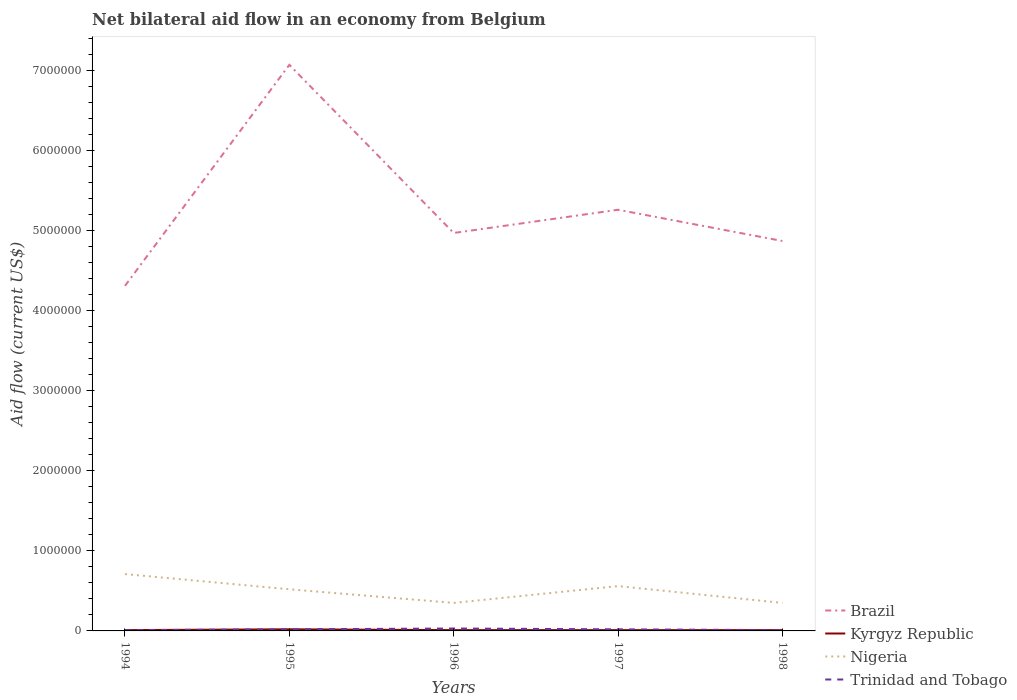How many different coloured lines are there?
Offer a terse response. 4. What is the total net bilateral aid flow in Kyrgyz Republic in the graph?
Provide a short and direct response. 10000. What is the difference between the highest and the lowest net bilateral aid flow in Kyrgyz Republic?
Your answer should be very brief. 1. What is the difference between two consecutive major ticks on the Y-axis?
Provide a short and direct response. 1.00e+06. Are the values on the major ticks of Y-axis written in scientific E-notation?
Your answer should be compact. No. Does the graph contain any zero values?
Your answer should be very brief. No. Does the graph contain grids?
Ensure brevity in your answer.  No. Where does the legend appear in the graph?
Provide a succinct answer. Bottom right. How are the legend labels stacked?
Give a very brief answer. Vertical. What is the title of the graph?
Offer a terse response. Net bilateral aid flow in an economy from Belgium. What is the Aid flow (current US$) of Brazil in 1994?
Your response must be concise. 4.31e+06. What is the Aid flow (current US$) in Nigeria in 1994?
Your answer should be very brief. 7.10e+05. What is the Aid flow (current US$) in Trinidad and Tobago in 1994?
Provide a short and direct response. 10000. What is the Aid flow (current US$) in Brazil in 1995?
Provide a succinct answer. 7.07e+06. What is the Aid flow (current US$) of Nigeria in 1995?
Provide a succinct answer. 5.20e+05. What is the Aid flow (current US$) of Brazil in 1996?
Keep it short and to the point. 4.97e+06. What is the Aid flow (current US$) of Kyrgyz Republic in 1996?
Keep it short and to the point. 10000. What is the Aid flow (current US$) in Nigeria in 1996?
Offer a terse response. 3.50e+05. What is the Aid flow (current US$) in Brazil in 1997?
Your response must be concise. 5.26e+06. What is the Aid flow (current US$) of Nigeria in 1997?
Give a very brief answer. 5.60e+05. What is the Aid flow (current US$) in Trinidad and Tobago in 1997?
Give a very brief answer. 2.00e+04. What is the Aid flow (current US$) in Brazil in 1998?
Offer a terse response. 4.87e+06. What is the Aid flow (current US$) in Kyrgyz Republic in 1998?
Your answer should be compact. 10000. Across all years, what is the maximum Aid flow (current US$) in Brazil?
Offer a very short reply. 7.07e+06. Across all years, what is the maximum Aid flow (current US$) in Kyrgyz Republic?
Provide a succinct answer. 2.00e+04. Across all years, what is the maximum Aid flow (current US$) in Nigeria?
Your answer should be very brief. 7.10e+05. Across all years, what is the minimum Aid flow (current US$) in Brazil?
Offer a terse response. 4.31e+06. Across all years, what is the minimum Aid flow (current US$) of Kyrgyz Republic?
Your response must be concise. 10000. Across all years, what is the minimum Aid flow (current US$) of Nigeria?
Your answer should be very brief. 3.50e+05. Across all years, what is the minimum Aid flow (current US$) in Trinidad and Tobago?
Your answer should be very brief. 10000. What is the total Aid flow (current US$) in Brazil in the graph?
Provide a short and direct response. 2.65e+07. What is the total Aid flow (current US$) in Nigeria in the graph?
Keep it short and to the point. 2.49e+06. What is the difference between the Aid flow (current US$) of Brazil in 1994 and that in 1995?
Your answer should be compact. -2.76e+06. What is the difference between the Aid flow (current US$) of Trinidad and Tobago in 1994 and that in 1995?
Provide a succinct answer. -10000. What is the difference between the Aid flow (current US$) in Brazil in 1994 and that in 1996?
Provide a succinct answer. -6.60e+05. What is the difference between the Aid flow (current US$) in Kyrgyz Republic in 1994 and that in 1996?
Provide a succinct answer. 0. What is the difference between the Aid flow (current US$) of Nigeria in 1994 and that in 1996?
Your answer should be compact. 3.60e+05. What is the difference between the Aid flow (current US$) in Brazil in 1994 and that in 1997?
Provide a succinct answer. -9.50e+05. What is the difference between the Aid flow (current US$) of Trinidad and Tobago in 1994 and that in 1997?
Ensure brevity in your answer.  -10000. What is the difference between the Aid flow (current US$) in Brazil in 1994 and that in 1998?
Your answer should be very brief. -5.60e+05. What is the difference between the Aid flow (current US$) in Trinidad and Tobago in 1994 and that in 1998?
Your answer should be very brief. 0. What is the difference between the Aid flow (current US$) of Brazil in 1995 and that in 1996?
Provide a short and direct response. 2.10e+06. What is the difference between the Aid flow (current US$) of Kyrgyz Republic in 1995 and that in 1996?
Offer a very short reply. 10000. What is the difference between the Aid flow (current US$) in Nigeria in 1995 and that in 1996?
Ensure brevity in your answer.  1.70e+05. What is the difference between the Aid flow (current US$) in Brazil in 1995 and that in 1997?
Keep it short and to the point. 1.81e+06. What is the difference between the Aid flow (current US$) of Kyrgyz Republic in 1995 and that in 1997?
Make the answer very short. 10000. What is the difference between the Aid flow (current US$) of Brazil in 1995 and that in 1998?
Offer a very short reply. 2.20e+06. What is the difference between the Aid flow (current US$) of Kyrgyz Republic in 1995 and that in 1998?
Provide a succinct answer. 10000. What is the difference between the Aid flow (current US$) in Nigeria in 1995 and that in 1998?
Provide a short and direct response. 1.70e+05. What is the difference between the Aid flow (current US$) in Brazil in 1996 and that in 1997?
Your answer should be compact. -2.90e+05. What is the difference between the Aid flow (current US$) in Kyrgyz Republic in 1996 and that in 1997?
Ensure brevity in your answer.  0. What is the difference between the Aid flow (current US$) in Brazil in 1996 and that in 1998?
Keep it short and to the point. 1.00e+05. What is the difference between the Aid flow (current US$) of Brazil in 1997 and that in 1998?
Make the answer very short. 3.90e+05. What is the difference between the Aid flow (current US$) in Nigeria in 1997 and that in 1998?
Your response must be concise. 2.10e+05. What is the difference between the Aid flow (current US$) in Brazil in 1994 and the Aid flow (current US$) in Kyrgyz Republic in 1995?
Your answer should be compact. 4.29e+06. What is the difference between the Aid flow (current US$) of Brazil in 1994 and the Aid flow (current US$) of Nigeria in 1995?
Your response must be concise. 3.79e+06. What is the difference between the Aid flow (current US$) in Brazil in 1994 and the Aid flow (current US$) in Trinidad and Tobago in 1995?
Offer a very short reply. 4.29e+06. What is the difference between the Aid flow (current US$) of Kyrgyz Republic in 1994 and the Aid flow (current US$) of Nigeria in 1995?
Offer a very short reply. -5.10e+05. What is the difference between the Aid flow (current US$) of Nigeria in 1994 and the Aid flow (current US$) of Trinidad and Tobago in 1995?
Offer a very short reply. 6.90e+05. What is the difference between the Aid flow (current US$) of Brazil in 1994 and the Aid flow (current US$) of Kyrgyz Republic in 1996?
Your response must be concise. 4.30e+06. What is the difference between the Aid flow (current US$) of Brazil in 1994 and the Aid flow (current US$) of Nigeria in 1996?
Your response must be concise. 3.96e+06. What is the difference between the Aid flow (current US$) in Brazil in 1994 and the Aid flow (current US$) in Trinidad and Tobago in 1996?
Offer a terse response. 4.28e+06. What is the difference between the Aid flow (current US$) in Nigeria in 1994 and the Aid flow (current US$) in Trinidad and Tobago in 1996?
Provide a short and direct response. 6.80e+05. What is the difference between the Aid flow (current US$) of Brazil in 1994 and the Aid flow (current US$) of Kyrgyz Republic in 1997?
Give a very brief answer. 4.30e+06. What is the difference between the Aid flow (current US$) of Brazil in 1994 and the Aid flow (current US$) of Nigeria in 1997?
Ensure brevity in your answer.  3.75e+06. What is the difference between the Aid flow (current US$) in Brazil in 1994 and the Aid flow (current US$) in Trinidad and Tobago in 1997?
Provide a short and direct response. 4.29e+06. What is the difference between the Aid flow (current US$) in Kyrgyz Republic in 1994 and the Aid flow (current US$) in Nigeria in 1997?
Give a very brief answer. -5.50e+05. What is the difference between the Aid flow (current US$) of Kyrgyz Republic in 1994 and the Aid flow (current US$) of Trinidad and Tobago in 1997?
Keep it short and to the point. -10000. What is the difference between the Aid flow (current US$) of Nigeria in 1994 and the Aid flow (current US$) of Trinidad and Tobago in 1997?
Make the answer very short. 6.90e+05. What is the difference between the Aid flow (current US$) of Brazil in 1994 and the Aid flow (current US$) of Kyrgyz Republic in 1998?
Your response must be concise. 4.30e+06. What is the difference between the Aid flow (current US$) in Brazil in 1994 and the Aid flow (current US$) in Nigeria in 1998?
Make the answer very short. 3.96e+06. What is the difference between the Aid flow (current US$) in Brazil in 1994 and the Aid flow (current US$) in Trinidad and Tobago in 1998?
Your answer should be compact. 4.30e+06. What is the difference between the Aid flow (current US$) in Brazil in 1995 and the Aid flow (current US$) in Kyrgyz Republic in 1996?
Offer a terse response. 7.06e+06. What is the difference between the Aid flow (current US$) in Brazil in 1995 and the Aid flow (current US$) in Nigeria in 1996?
Your response must be concise. 6.72e+06. What is the difference between the Aid flow (current US$) in Brazil in 1995 and the Aid flow (current US$) in Trinidad and Tobago in 1996?
Keep it short and to the point. 7.04e+06. What is the difference between the Aid flow (current US$) in Kyrgyz Republic in 1995 and the Aid flow (current US$) in Nigeria in 1996?
Your response must be concise. -3.30e+05. What is the difference between the Aid flow (current US$) of Kyrgyz Republic in 1995 and the Aid flow (current US$) of Trinidad and Tobago in 1996?
Keep it short and to the point. -10000. What is the difference between the Aid flow (current US$) in Nigeria in 1995 and the Aid flow (current US$) in Trinidad and Tobago in 1996?
Provide a succinct answer. 4.90e+05. What is the difference between the Aid flow (current US$) of Brazil in 1995 and the Aid flow (current US$) of Kyrgyz Republic in 1997?
Your response must be concise. 7.06e+06. What is the difference between the Aid flow (current US$) in Brazil in 1995 and the Aid flow (current US$) in Nigeria in 1997?
Give a very brief answer. 6.51e+06. What is the difference between the Aid flow (current US$) in Brazil in 1995 and the Aid flow (current US$) in Trinidad and Tobago in 1997?
Your response must be concise. 7.05e+06. What is the difference between the Aid flow (current US$) of Kyrgyz Republic in 1995 and the Aid flow (current US$) of Nigeria in 1997?
Your response must be concise. -5.40e+05. What is the difference between the Aid flow (current US$) of Brazil in 1995 and the Aid flow (current US$) of Kyrgyz Republic in 1998?
Give a very brief answer. 7.06e+06. What is the difference between the Aid flow (current US$) of Brazil in 1995 and the Aid flow (current US$) of Nigeria in 1998?
Offer a terse response. 6.72e+06. What is the difference between the Aid flow (current US$) of Brazil in 1995 and the Aid flow (current US$) of Trinidad and Tobago in 1998?
Offer a terse response. 7.06e+06. What is the difference between the Aid flow (current US$) in Kyrgyz Republic in 1995 and the Aid flow (current US$) in Nigeria in 1998?
Your answer should be very brief. -3.30e+05. What is the difference between the Aid flow (current US$) in Nigeria in 1995 and the Aid flow (current US$) in Trinidad and Tobago in 1998?
Your answer should be very brief. 5.10e+05. What is the difference between the Aid flow (current US$) of Brazil in 1996 and the Aid flow (current US$) of Kyrgyz Republic in 1997?
Give a very brief answer. 4.96e+06. What is the difference between the Aid flow (current US$) in Brazil in 1996 and the Aid flow (current US$) in Nigeria in 1997?
Your answer should be very brief. 4.41e+06. What is the difference between the Aid flow (current US$) of Brazil in 1996 and the Aid flow (current US$) of Trinidad and Tobago in 1997?
Your response must be concise. 4.95e+06. What is the difference between the Aid flow (current US$) in Kyrgyz Republic in 1996 and the Aid flow (current US$) in Nigeria in 1997?
Offer a very short reply. -5.50e+05. What is the difference between the Aid flow (current US$) in Nigeria in 1996 and the Aid flow (current US$) in Trinidad and Tobago in 1997?
Your answer should be very brief. 3.30e+05. What is the difference between the Aid flow (current US$) of Brazil in 1996 and the Aid flow (current US$) of Kyrgyz Republic in 1998?
Your answer should be very brief. 4.96e+06. What is the difference between the Aid flow (current US$) of Brazil in 1996 and the Aid flow (current US$) of Nigeria in 1998?
Keep it short and to the point. 4.62e+06. What is the difference between the Aid flow (current US$) of Brazil in 1996 and the Aid flow (current US$) of Trinidad and Tobago in 1998?
Your answer should be compact. 4.96e+06. What is the difference between the Aid flow (current US$) in Brazil in 1997 and the Aid flow (current US$) in Kyrgyz Republic in 1998?
Keep it short and to the point. 5.25e+06. What is the difference between the Aid flow (current US$) in Brazil in 1997 and the Aid flow (current US$) in Nigeria in 1998?
Keep it short and to the point. 4.91e+06. What is the difference between the Aid flow (current US$) in Brazil in 1997 and the Aid flow (current US$) in Trinidad and Tobago in 1998?
Keep it short and to the point. 5.25e+06. What is the difference between the Aid flow (current US$) in Kyrgyz Republic in 1997 and the Aid flow (current US$) in Nigeria in 1998?
Your answer should be compact. -3.40e+05. What is the difference between the Aid flow (current US$) of Nigeria in 1997 and the Aid flow (current US$) of Trinidad and Tobago in 1998?
Provide a short and direct response. 5.50e+05. What is the average Aid flow (current US$) of Brazil per year?
Ensure brevity in your answer.  5.30e+06. What is the average Aid flow (current US$) of Kyrgyz Republic per year?
Offer a terse response. 1.20e+04. What is the average Aid flow (current US$) in Nigeria per year?
Ensure brevity in your answer.  4.98e+05. What is the average Aid flow (current US$) of Trinidad and Tobago per year?
Keep it short and to the point. 1.80e+04. In the year 1994, what is the difference between the Aid flow (current US$) in Brazil and Aid flow (current US$) in Kyrgyz Republic?
Provide a succinct answer. 4.30e+06. In the year 1994, what is the difference between the Aid flow (current US$) of Brazil and Aid flow (current US$) of Nigeria?
Give a very brief answer. 3.60e+06. In the year 1994, what is the difference between the Aid flow (current US$) of Brazil and Aid flow (current US$) of Trinidad and Tobago?
Your answer should be very brief. 4.30e+06. In the year 1994, what is the difference between the Aid flow (current US$) in Kyrgyz Republic and Aid flow (current US$) in Nigeria?
Give a very brief answer. -7.00e+05. In the year 1994, what is the difference between the Aid flow (current US$) in Kyrgyz Republic and Aid flow (current US$) in Trinidad and Tobago?
Keep it short and to the point. 0. In the year 1994, what is the difference between the Aid flow (current US$) of Nigeria and Aid flow (current US$) of Trinidad and Tobago?
Make the answer very short. 7.00e+05. In the year 1995, what is the difference between the Aid flow (current US$) in Brazil and Aid flow (current US$) in Kyrgyz Republic?
Make the answer very short. 7.05e+06. In the year 1995, what is the difference between the Aid flow (current US$) in Brazil and Aid flow (current US$) in Nigeria?
Offer a terse response. 6.55e+06. In the year 1995, what is the difference between the Aid flow (current US$) of Brazil and Aid flow (current US$) of Trinidad and Tobago?
Provide a short and direct response. 7.05e+06. In the year 1995, what is the difference between the Aid flow (current US$) in Kyrgyz Republic and Aid flow (current US$) in Nigeria?
Your answer should be compact. -5.00e+05. In the year 1995, what is the difference between the Aid flow (current US$) in Kyrgyz Republic and Aid flow (current US$) in Trinidad and Tobago?
Give a very brief answer. 0. In the year 1995, what is the difference between the Aid flow (current US$) in Nigeria and Aid flow (current US$) in Trinidad and Tobago?
Keep it short and to the point. 5.00e+05. In the year 1996, what is the difference between the Aid flow (current US$) in Brazil and Aid flow (current US$) in Kyrgyz Republic?
Keep it short and to the point. 4.96e+06. In the year 1996, what is the difference between the Aid flow (current US$) of Brazil and Aid flow (current US$) of Nigeria?
Your response must be concise. 4.62e+06. In the year 1996, what is the difference between the Aid flow (current US$) in Brazil and Aid flow (current US$) in Trinidad and Tobago?
Make the answer very short. 4.94e+06. In the year 1996, what is the difference between the Aid flow (current US$) of Kyrgyz Republic and Aid flow (current US$) of Nigeria?
Ensure brevity in your answer.  -3.40e+05. In the year 1996, what is the difference between the Aid flow (current US$) of Nigeria and Aid flow (current US$) of Trinidad and Tobago?
Ensure brevity in your answer.  3.20e+05. In the year 1997, what is the difference between the Aid flow (current US$) of Brazil and Aid flow (current US$) of Kyrgyz Republic?
Provide a short and direct response. 5.25e+06. In the year 1997, what is the difference between the Aid flow (current US$) of Brazil and Aid flow (current US$) of Nigeria?
Provide a short and direct response. 4.70e+06. In the year 1997, what is the difference between the Aid flow (current US$) of Brazil and Aid flow (current US$) of Trinidad and Tobago?
Give a very brief answer. 5.24e+06. In the year 1997, what is the difference between the Aid flow (current US$) in Kyrgyz Republic and Aid flow (current US$) in Nigeria?
Offer a terse response. -5.50e+05. In the year 1997, what is the difference between the Aid flow (current US$) of Nigeria and Aid flow (current US$) of Trinidad and Tobago?
Offer a terse response. 5.40e+05. In the year 1998, what is the difference between the Aid flow (current US$) of Brazil and Aid flow (current US$) of Kyrgyz Republic?
Offer a terse response. 4.86e+06. In the year 1998, what is the difference between the Aid flow (current US$) of Brazil and Aid flow (current US$) of Nigeria?
Give a very brief answer. 4.52e+06. In the year 1998, what is the difference between the Aid flow (current US$) of Brazil and Aid flow (current US$) of Trinidad and Tobago?
Offer a very short reply. 4.86e+06. In the year 1998, what is the difference between the Aid flow (current US$) in Nigeria and Aid flow (current US$) in Trinidad and Tobago?
Your answer should be compact. 3.40e+05. What is the ratio of the Aid flow (current US$) in Brazil in 1994 to that in 1995?
Provide a short and direct response. 0.61. What is the ratio of the Aid flow (current US$) of Nigeria in 1994 to that in 1995?
Make the answer very short. 1.37. What is the ratio of the Aid flow (current US$) of Trinidad and Tobago in 1994 to that in 1995?
Your answer should be very brief. 0.5. What is the ratio of the Aid flow (current US$) in Brazil in 1994 to that in 1996?
Offer a terse response. 0.87. What is the ratio of the Aid flow (current US$) in Nigeria in 1994 to that in 1996?
Provide a short and direct response. 2.03. What is the ratio of the Aid flow (current US$) in Brazil in 1994 to that in 1997?
Keep it short and to the point. 0.82. What is the ratio of the Aid flow (current US$) in Nigeria in 1994 to that in 1997?
Offer a terse response. 1.27. What is the ratio of the Aid flow (current US$) of Brazil in 1994 to that in 1998?
Keep it short and to the point. 0.89. What is the ratio of the Aid flow (current US$) in Nigeria in 1994 to that in 1998?
Make the answer very short. 2.03. What is the ratio of the Aid flow (current US$) in Brazil in 1995 to that in 1996?
Offer a very short reply. 1.42. What is the ratio of the Aid flow (current US$) in Nigeria in 1995 to that in 1996?
Keep it short and to the point. 1.49. What is the ratio of the Aid flow (current US$) of Brazil in 1995 to that in 1997?
Offer a very short reply. 1.34. What is the ratio of the Aid flow (current US$) in Trinidad and Tobago in 1995 to that in 1997?
Give a very brief answer. 1. What is the ratio of the Aid flow (current US$) of Brazil in 1995 to that in 1998?
Provide a succinct answer. 1.45. What is the ratio of the Aid flow (current US$) in Nigeria in 1995 to that in 1998?
Ensure brevity in your answer.  1.49. What is the ratio of the Aid flow (current US$) in Trinidad and Tobago in 1995 to that in 1998?
Provide a short and direct response. 2. What is the ratio of the Aid flow (current US$) in Brazil in 1996 to that in 1997?
Make the answer very short. 0.94. What is the ratio of the Aid flow (current US$) in Trinidad and Tobago in 1996 to that in 1997?
Provide a succinct answer. 1.5. What is the ratio of the Aid flow (current US$) of Brazil in 1996 to that in 1998?
Provide a short and direct response. 1.02. What is the ratio of the Aid flow (current US$) of Kyrgyz Republic in 1996 to that in 1998?
Ensure brevity in your answer.  1. What is the ratio of the Aid flow (current US$) of Brazil in 1997 to that in 1998?
Keep it short and to the point. 1.08. What is the ratio of the Aid flow (current US$) of Kyrgyz Republic in 1997 to that in 1998?
Give a very brief answer. 1. What is the ratio of the Aid flow (current US$) in Nigeria in 1997 to that in 1998?
Your response must be concise. 1.6. What is the difference between the highest and the second highest Aid flow (current US$) in Brazil?
Give a very brief answer. 1.81e+06. What is the difference between the highest and the second highest Aid flow (current US$) of Kyrgyz Republic?
Offer a terse response. 10000. What is the difference between the highest and the second highest Aid flow (current US$) of Nigeria?
Provide a succinct answer. 1.50e+05. What is the difference between the highest and the lowest Aid flow (current US$) of Brazil?
Your answer should be compact. 2.76e+06. 